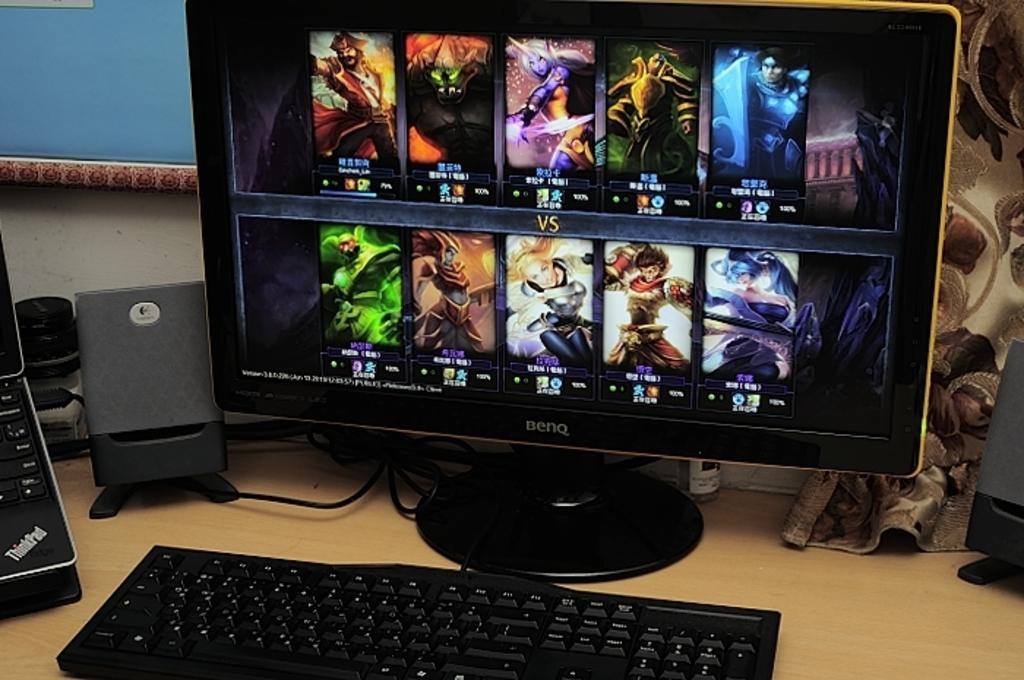<image>
Provide a brief description of the given image. A Benq computer shows a bunch of video game characters. 